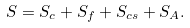<formula> <loc_0><loc_0><loc_500><loc_500>S = S _ { c } + S _ { f } + S _ { c s } + S _ { A } .</formula> 